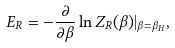<formula> <loc_0><loc_0><loc_500><loc_500>E _ { R } = - { \frac { \partial } { \partial \beta } } \ln Z _ { R } ( \beta ) | _ { \beta = \beta _ { H } } ,</formula> 